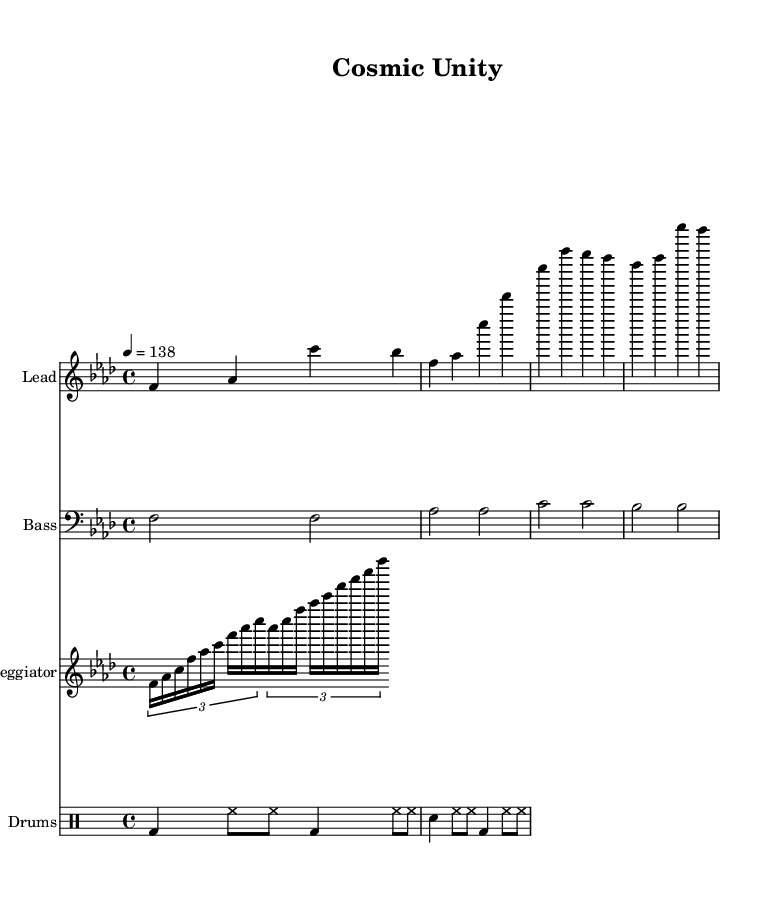What is the key signature of this music? The key signature is F minor, which includes four flats (B, E, A, and D). This can be determined by looking at the key signature indicated at the beginning of the staff.
Answer: F minor What is the time signature of this music? The time signature is 4/4, which can be seen right after the key signature. This indicates that there are four beats in each measure and that the quarter note gets one beat.
Answer: 4/4 What is the tempo marking for this piece? The tempo marking indicates the speed of the music, specifically set to 138 beats per minute. This is noted by the "4 = 138" tempo indication at the beginning of the score.
Answer: 138 How many measures are in the main melody? The main melody consists of four measures. Each group of notes under the "Lead" staff is separated by bar lines, which define individual measures, and counting these gives a total of four.
Answer: 4 What type of drum pattern is used in this music? The drum pattern utilizes a standard dance rhythm which incorporates kick (bass drum), hi-hat, and snare in a repetitive structure. This is discerned from the drum notation that shows the distinct beats associated with each drum instrument.
Answer: Dance rhythm Which instruments are featured in this score? The score features four distinct instruments: Lead (melody), Bass, Arpeggiator, and Drums. This can be identified at the left side of each staff where the instruments are labeled.
Answer: Lead, Bass, Arpeggiator, Drums What is the primary theme of the music? The primary theme of the music is teamwork and overcoming challenges. This theme can be inferred from the title "Cosmic Unity," suggesting a collaborative spirit, typical of high-energy trance music.
Answer: Teamwork and overcoming challenges 